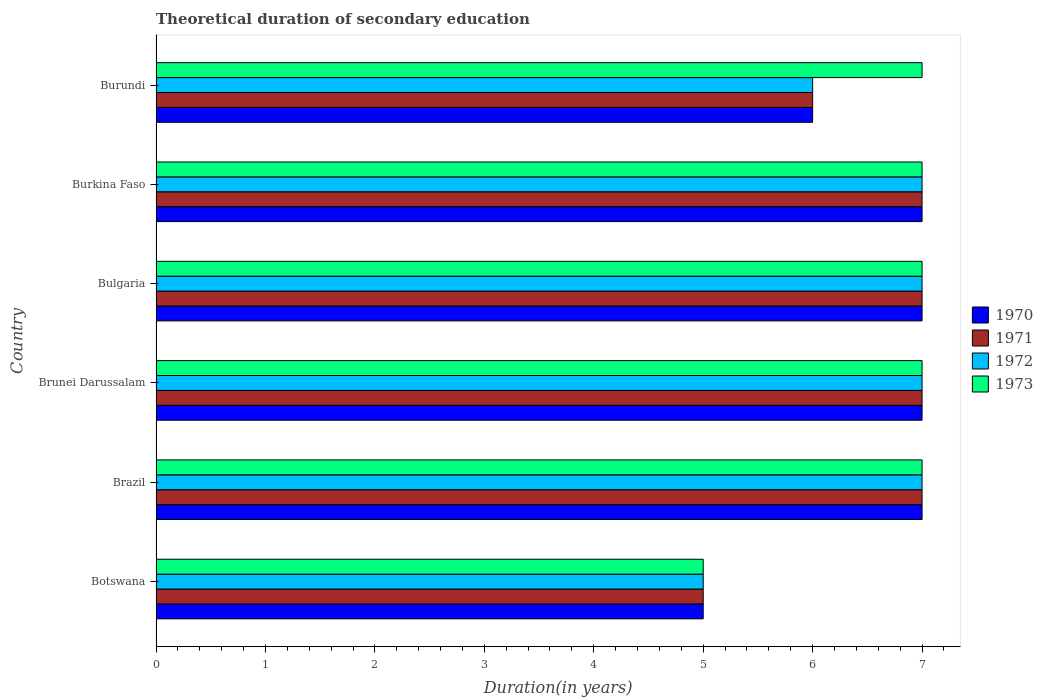How many groups of bars are there?
Give a very brief answer. 6. Are the number of bars per tick equal to the number of legend labels?
Your answer should be compact. Yes. Are the number of bars on each tick of the Y-axis equal?
Your answer should be compact. Yes. How many bars are there on the 1st tick from the bottom?
Ensure brevity in your answer.  4. What is the label of the 1st group of bars from the top?
Offer a very short reply. Burundi. In how many cases, is the number of bars for a given country not equal to the number of legend labels?
Offer a very short reply. 0. Across all countries, what is the maximum total theoretical duration of secondary education in 1971?
Provide a succinct answer. 7. In which country was the total theoretical duration of secondary education in 1970 maximum?
Offer a terse response. Brazil. In which country was the total theoretical duration of secondary education in 1970 minimum?
Ensure brevity in your answer.  Botswana. What is the difference between the total theoretical duration of secondary education in 1972 in Brazil and the total theoretical duration of secondary education in 1973 in Bulgaria?
Make the answer very short. 0. What is the average total theoretical duration of secondary education in 1972 per country?
Your answer should be compact. 6.5. What is the ratio of the total theoretical duration of secondary education in 1970 in Botswana to that in Burundi?
Your answer should be compact. 0.83. What is the difference between the highest and the lowest total theoretical duration of secondary education in 1971?
Give a very brief answer. 2. In how many countries, is the total theoretical duration of secondary education in 1971 greater than the average total theoretical duration of secondary education in 1971 taken over all countries?
Offer a very short reply. 4. Is the sum of the total theoretical duration of secondary education in 1972 in Brazil and Brunei Darussalam greater than the maximum total theoretical duration of secondary education in 1973 across all countries?
Provide a short and direct response. Yes. How many bars are there?
Your response must be concise. 24. Are all the bars in the graph horizontal?
Offer a terse response. Yes. How many countries are there in the graph?
Offer a very short reply. 6. What is the difference between two consecutive major ticks on the X-axis?
Give a very brief answer. 1. Where does the legend appear in the graph?
Your answer should be compact. Center right. How many legend labels are there?
Provide a succinct answer. 4. What is the title of the graph?
Offer a terse response. Theoretical duration of secondary education. Does "1995" appear as one of the legend labels in the graph?
Give a very brief answer. No. What is the label or title of the X-axis?
Make the answer very short. Duration(in years). What is the Duration(in years) in 1970 in Botswana?
Your answer should be compact. 5. What is the Duration(in years) in 1973 in Botswana?
Offer a very short reply. 5. What is the Duration(in years) of 1971 in Brazil?
Give a very brief answer. 7. What is the Duration(in years) in 1972 in Brazil?
Keep it short and to the point. 7. What is the Duration(in years) in 1971 in Brunei Darussalam?
Give a very brief answer. 7. What is the Duration(in years) of 1973 in Brunei Darussalam?
Offer a very short reply. 7. What is the Duration(in years) of 1971 in Bulgaria?
Provide a succinct answer. 7. What is the Duration(in years) in 1970 in Burkina Faso?
Offer a very short reply. 7. What is the Duration(in years) in 1973 in Burkina Faso?
Your answer should be compact. 7. What is the Duration(in years) in 1971 in Burundi?
Keep it short and to the point. 6. Across all countries, what is the maximum Duration(in years) in 1971?
Provide a short and direct response. 7. Across all countries, what is the minimum Duration(in years) of 1971?
Keep it short and to the point. 5. What is the total Duration(in years) of 1971 in the graph?
Provide a short and direct response. 39. What is the difference between the Duration(in years) in 1972 in Botswana and that in Brazil?
Offer a terse response. -2. What is the difference between the Duration(in years) in 1973 in Botswana and that in Brazil?
Your answer should be compact. -2. What is the difference between the Duration(in years) in 1970 in Botswana and that in Brunei Darussalam?
Ensure brevity in your answer.  -2. What is the difference between the Duration(in years) of 1971 in Botswana and that in Brunei Darussalam?
Provide a short and direct response. -2. What is the difference between the Duration(in years) of 1973 in Botswana and that in Brunei Darussalam?
Provide a succinct answer. -2. What is the difference between the Duration(in years) of 1973 in Botswana and that in Bulgaria?
Your answer should be compact. -2. What is the difference between the Duration(in years) in 1970 in Botswana and that in Burkina Faso?
Your answer should be compact. -2. What is the difference between the Duration(in years) of 1971 in Botswana and that in Burkina Faso?
Offer a terse response. -2. What is the difference between the Duration(in years) in 1972 in Botswana and that in Burkina Faso?
Make the answer very short. -2. What is the difference between the Duration(in years) in 1970 in Botswana and that in Burundi?
Keep it short and to the point. -1. What is the difference between the Duration(in years) in 1972 in Botswana and that in Burundi?
Offer a very short reply. -1. What is the difference between the Duration(in years) in 1970 in Brazil and that in Bulgaria?
Ensure brevity in your answer.  0. What is the difference between the Duration(in years) in 1973 in Brazil and that in Bulgaria?
Give a very brief answer. 0. What is the difference between the Duration(in years) of 1970 in Brazil and that in Burundi?
Ensure brevity in your answer.  1. What is the difference between the Duration(in years) of 1972 in Brazil and that in Burundi?
Keep it short and to the point. 1. What is the difference between the Duration(in years) in 1970 in Brunei Darussalam and that in Bulgaria?
Ensure brevity in your answer.  0. What is the difference between the Duration(in years) of 1972 in Brunei Darussalam and that in Burkina Faso?
Make the answer very short. 0. What is the difference between the Duration(in years) of 1971 in Brunei Darussalam and that in Burundi?
Provide a short and direct response. 1. What is the difference between the Duration(in years) in 1970 in Bulgaria and that in Burkina Faso?
Provide a succinct answer. 0. What is the difference between the Duration(in years) of 1973 in Bulgaria and that in Burkina Faso?
Make the answer very short. 0. What is the difference between the Duration(in years) in 1970 in Bulgaria and that in Burundi?
Provide a succinct answer. 1. What is the difference between the Duration(in years) of 1971 in Bulgaria and that in Burundi?
Give a very brief answer. 1. What is the difference between the Duration(in years) in 1972 in Bulgaria and that in Burundi?
Offer a terse response. 1. What is the difference between the Duration(in years) in 1973 in Bulgaria and that in Burundi?
Give a very brief answer. 0. What is the difference between the Duration(in years) of 1971 in Burkina Faso and that in Burundi?
Your answer should be compact. 1. What is the difference between the Duration(in years) of 1970 in Botswana and the Duration(in years) of 1973 in Brazil?
Your response must be concise. -2. What is the difference between the Duration(in years) of 1970 in Botswana and the Duration(in years) of 1971 in Brunei Darussalam?
Make the answer very short. -2. What is the difference between the Duration(in years) in 1970 in Botswana and the Duration(in years) in 1972 in Brunei Darussalam?
Your answer should be very brief. -2. What is the difference between the Duration(in years) of 1970 in Botswana and the Duration(in years) of 1973 in Brunei Darussalam?
Make the answer very short. -2. What is the difference between the Duration(in years) of 1971 in Botswana and the Duration(in years) of 1972 in Brunei Darussalam?
Ensure brevity in your answer.  -2. What is the difference between the Duration(in years) of 1971 in Botswana and the Duration(in years) of 1973 in Brunei Darussalam?
Keep it short and to the point. -2. What is the difference between the Duration(in years) in 1972 in Botswana and the Duration(in years) in 1973 in Brunei Darussalam?
Keep it short and to the point. -2. What is the difference between the Duration(in years) in 1972 in Botswana and the Duration(in years) in 1973 in Bulgaria?
Offer a terse response. -2. What is the difference between the Duration(in years) in 1970 in Botswana and the Duration(in years) in 1971 in Burkina Faso?
Ensure brevity in your answer.  -2. What is the difference between the Duration(in years) in 1971 in Botswana and the Duration(in years) in 1972 in Burkina Faso?
Your answer should be compact. -2. What is the difference between the Duration(in years) in 1970 in Botswana and the Duration(in years) in 1971 in Burundi?
Your answer should be compact. -1. What is the difference between the Duration(in years) in 1970 in Botswana and the Duration(in years) in 1973 in Burundi?
Your answer should be very brief. -2. What is the difference between the Duration(in years) of 1971 in Botswana and the Duration(in years) of 1972 in Burundi?
Give a very brief answer. -1. What is the difference between the Duration(in years) of 1971 in Botswana and the Duration(in years) of 1973 in Burundi?
Your response must be concise. -2. What is the difference between the Duration(in years) of 1972 in Botswana and the Duration(in years) of 1973 in Burundi?
Ensure brevity in your answer.  -2. What is the difference between the Duration(in years) of 1970 in Brazil and the Duration(in years) of 1971 in Brunei Darussalam?
Provide a short and direct response. 0. What is the difference between the Duration(in years) in 1970 in Brazil and the Duration(in years) in 1972 in Brunei Darussalam?
Your response must be concise. 0. What is the difference between the Duration(in years) of 1970 in Brazil and the Duration(in years) of 1973 in Brunei Darussalam?
Your response must be concise. 0. What is the difference between the Duration(in years) in 1971 in Brazil and the Duration(in years) in 1973 in Brunei Darussalam?
Your response must be concise. 0. What is the difference between the Duration(in years) of 1970 in Brazil and the Duration(in years) of 1973 in Bulgaria?
Offer a terse response. 0. What is the difference between the Duration(in years) in 1970 in Brazil and the Duration(in years) in 1971 in Burkina Faso?
Your answer should be very brief. 0. What is the difference between the Duration(in years) of 1970 in Brazil and the Duration(in years) of 1973 in Burkina Faso?
Your answer should be very brief. 0. What is the difference between the Duration(in years) of 1971 in Brazil and the Duration(in years) of 1972 in Burkina Faso?
Your response must be concise. 0. What is the difference between the Duration(in years) in 1971 in Brazil and the Duration(in years) in 1973 in Burkina Faso?
Make the answer very short. 0. What is the difference between the Duration(in years) of 1970 in Brazil and the Duration(in years) of 1971 in Burundi?
Your answer should be compact. 1. What is the difference between the Duration(in years) of 1970 in Brazil and the Duration(in years) of 1972 in Burundi?
Make the answer very short. 1. What is the difference between the Duration(in years) in 1970 in Brazil and the Duration(in years) in 1973 in Burundi?
Ensure brevity in your answer.  0. What is the difference between the Duration(in years) of 1971 in Brazil and the Duration(in years) of 1972 in Burundi?
Make the answer very short. 1. What is the difference between the Duration(in years) of 1972 in Brazil and the Duration(in years) of 1973 in Burundi?
Make the answer very short. 0. What is the difference between the Duration(in years) in 1970 in Brunei Darussalam and the Duration(in years) in 1972 in Bulgaria?
Your answer should be compact. 0. What is the difference between the Duration(in years) in 1970 in Brunei Darussalam and the Duration(in years) in 1973 in Bulgaria?
Give a very brief answer. 0. What is the difference between the Duration(in years) of 1971 in Brunei Darussalam and the Duration(in years) of 1972 in Bulgaria?
Your answer should be very brief. 0. What is the difference between the Duration(in years) in 1971 in Brunei Darussalam and the Duration(in years) in 1973 in Bulgaria?
Offer a very short reply. 0. What is the difference between the Duration(in years) of 1970 in Brunei Darussalam and the Duration(in years) of 1971 in Burkina Faso?
Offer a terse response. 0. What is the difference between the Duration(in years) in 1970 in Brunei Darussalam and the Duration(in years) in 1972 in Burkina Faso?
Your answer should be very brief. 0. What is the difference between the Duration(in years) in 1971 in Brunei Darussalam and the Duration(in years) in 1972 in Burkina Faso?
Provide a succinct answer. 0. What is the difference between the Duration(in years) in 1970 in Brunei Darussalam and the Duration(in years) in 1971 in Burundi?
Give a very brief answer. 1. What is the difference between the Duration(in years) of 1970 in Brunei Darussalam and the Duration(in years) of 1973 in Burundi?
Provide a short and direct response. 0. What is the difference between the Duration(in years) of 1972 in Brunei Darussalam and the Duration(in years) of 1973 in Burundi?
Your answer should be compact. 0. What is the difference between the Duration(in years) in 1970 in Bulgaria and the Duration(in years) in 1971 in Burkina Faso?
Your answer should be compact. 0. What is the difference between the Duration(in years) in 1970 in Bulgaria and the Duration(in years) in 1972 in Burkina Faso?
Ensure brevity in your answer.  0. What is the difference between the Duration(in years) of 1971 in Bulgaria and the Duration(in years) of 1972 in Burkina Faso?
Keep it short and to the point. 0. What is the difference between the Duration(in years) of 1970 in Bulgaria and the Duration(in years) of 1972 in Burundi?
Provide a succinct answer. 1. What is the difference between the Duration(in years) of 1970 in Bulgaria and the Duration(in years) of 1973 in Burundi?
Offer a very short reply. 0. What is the difference between the Duration(in years) of 1971 in Bulgaria and the Duration(in years) of 1972 in Burundi?
Your response must be concise. 1. What is the difference between the Duration(in years) in 1971 in Bulgaria and the Duration(in years) in 1973 in Burundi?
Your response must be concise. 0. What is the difference between the Duration(in years) of 1972 in Bulgaria and the Duration(in years) of 1973 in Burundi?
Your answer should be compact. 0. What is the difference between the Duration(in years) in 1970 in Burkina Faso and the Duration(in years) in 1971 in Burundi?
Keep it short and to the point. 1. What is the difference between the Duration(in years) in 1970 in Burkina Faso and the Duration(in years) in 1973 in Burundi?
Keep it short and to the point. 0. What is the average Duration(in years) of 1970 per country?
Provide a short and direct response. 6.5. What is the average Duration(in years) in 1972 per country?
Your answer should be compact. 6.5. What is the difference between the Duration(in years) in 1970 and Duration(in years) in 1971 in Botswana?
Ensure brevity in your answer.  0. What is the difference between the Duration(in years) in 1970 and Duration(in years) in 1973 in Botswana?
Provide a short and direct response. 0. What is the difference between the Duration(in years) of 1970 and Duration(in years) of 1971 in Brazil?
Make the answer very short. 0. What is the difference between the Duration(in years) of 1970 and Duration(in years) of 1973 in Brazil?
Your response must be concise. 0. What is the difference between the Duration(in years) of 1971 and Duration(in years) of 1972 in Brazil?
Ensure brevity in your answer.  0. What is the difference between the Duration(in years) in 1972 and Duration(in years) in 1973 in Brazil?
Provide a succinct answer. 0. What is the difference between the Duration(in years) in 1971 and Duration(in years) in 1972 in Brunei Darussalam?
Offer a terse response. 0. What is the difference between the Duration(in years) in 1970 and Duration(in years) in 1971 in Bulgaria?
Keep it short and to the point. 0. What is the difference between the Duration(in years) in 1971 and Duration(in years) in 1972 in Bulgaria?
Ensure brevity in your answer.  0. What is the difference between the Duration(in years) of 1971 and Duration(in years) of 1972 in Burkina Faso?
Your answer should be very brief. 0. What is the difference between the Duration(in years) in 1971 and Duration(in years) in 1973 in Burkina Faso?
Keep it short and to the point. 0. What is the difference between the Duration(in years) in 1970 and Duration(in years) in 1972 in Burundi?
Your answer should be compact. 0. What is the difference between the Duration(in years) of 1971 and Duration(in years) of 1973 in Burundi?
Your answer should be very brief. -1. What is the difference between the Duration(in years) in 1972 and Duration(in years) in 1973 in Burundi?
Keep it short and to the point. -1. What is the ratio of the Duration(in years) of 1970 in Botswana to that in Brunei Darussalam?
Offer a very short reply. 0.71. What is the ratio of the Duration(in years) of 1971 in Botswana to that in Brunei Darussalam?
Ensure brevity in your answer.  0.71. What is the ratio of the Duration(in years) in 1973 in Botswana to that in Bulgaria?
Offer a terse response. 0.71. What is the ratio of the Duration(in years) of 1970 in Botswana to that in Burkina Faso?
Offer a terse response. 0.71. What is the ratio of the Duration(in years) in 1973 in Botswana to that in Burkina Faso?
Give a very brief answer. 0.71. What is the ratio of the Duration(in years) of 1971 in Botswana to that in Burundi?
Your answer should be compact. 0.83. What is the ratio of the Duration(in years) of 1970 in Brazil to that in Brunei Darussalam?
Give a very brief answer. 1. What is the ratio of the Duration(in years) of 1970 in Brazil to that in Bulgaria?
Keep it short and to the point. 1. What is the ratio of the Duration(in years) in 1973 in Brazil to that in Bulgaria?
Provide a short and direct response. 1. What is the ratio of the Duration(in years) in 1970 in Brazil to that in Burkina Faso?
Offer a very short reply. 1. What is the ratio of the Duration(in years) of 1972 in Brazil to that in Burkina Faso?
Ensure brevity in your answer.  1. What is the ratio of the Duration(in years) in 1973 in Brazil to that in Burkina Faso?
Keep it short and to the point. 1. What is the ratio of the Duration(in years) of 1972 in Brazil to that in Burundi?
Offer a terse response. 1.17. What is the ratio of the Duration(in years) of 1973 in Brazil to that in Burundi?
Provide a short and direct response. 1. What is the ratio of the Duration(in years) in 1970 in Brunei Darussalam to that in Bulgaria?
Offer a very short reply. 1. What is the ratio of the Duration(in years) in 1971 in Brunei Darussalam to that in Burkina Faso?
Offer a very short reply. 1. What is the ratio of the Duration(in years) of 1970 in Brunei Darussalam to that in Burundi?
Provide a succinct answer. 1.17. What is the ratio of the Duration(in years) in 1971 in Brunei Darussalam to that in Burundi?
Give a very brief answer. 1.17. What is the ratio of the Duration(in years) in 1972 in Brunei Darussalam to that in Burundi?
Give a very brief answer. 1.17. What is the ratio of the Duration(in years) in 1970 in Bulgaria to that in Burkina Faso?
Your answer should be compact. 1. What is the ratio of the Duration(in years) of 1971 in Bulgaria to that in Burkina Faso?
Provide a short and direct response. 1. What is the ratio of the Duration(in years) in 1973 in Bulgaria to that in Burkina Faso?
Offer a very short reply. 1. What is the ratio of the Duration(in years) in 1971 in Bulgaria to that in Burundi?
Keep it short and to the point. 1.17. What is the ratio of the Duration(in years) in 1972 in Bulgaria to that in Burundi?
Offer a terse response. 1.17. What is the ratio of the Duration(in years) in 1973 in Bulgaria to that in Burundi?
Provide a short and direct response. 1. What is the ratio of the Duration(in years) of 1970 in Burkina Faso to that in Burundi?
Provide a succinct answer. 1.17. What is the ratio of the Duration(in years) of 1971 in Burkina Faso to that in Burundi?
Offer a terse response. 1.17. What is the difference between the highest and the second highest Duration(in years) in 1971?
Your answer should be compact. 0. What is the difference between the highest and the lowest Duration(in years) of 1972?
Your answer should be compact. 2. 